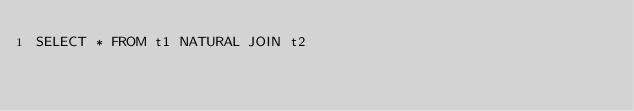Convert code to text. <code><loc_0><loc_0><loc_500><loc_500><_SQL_>SELECT * FROM t1 NATURAL JOIN t2</code> 